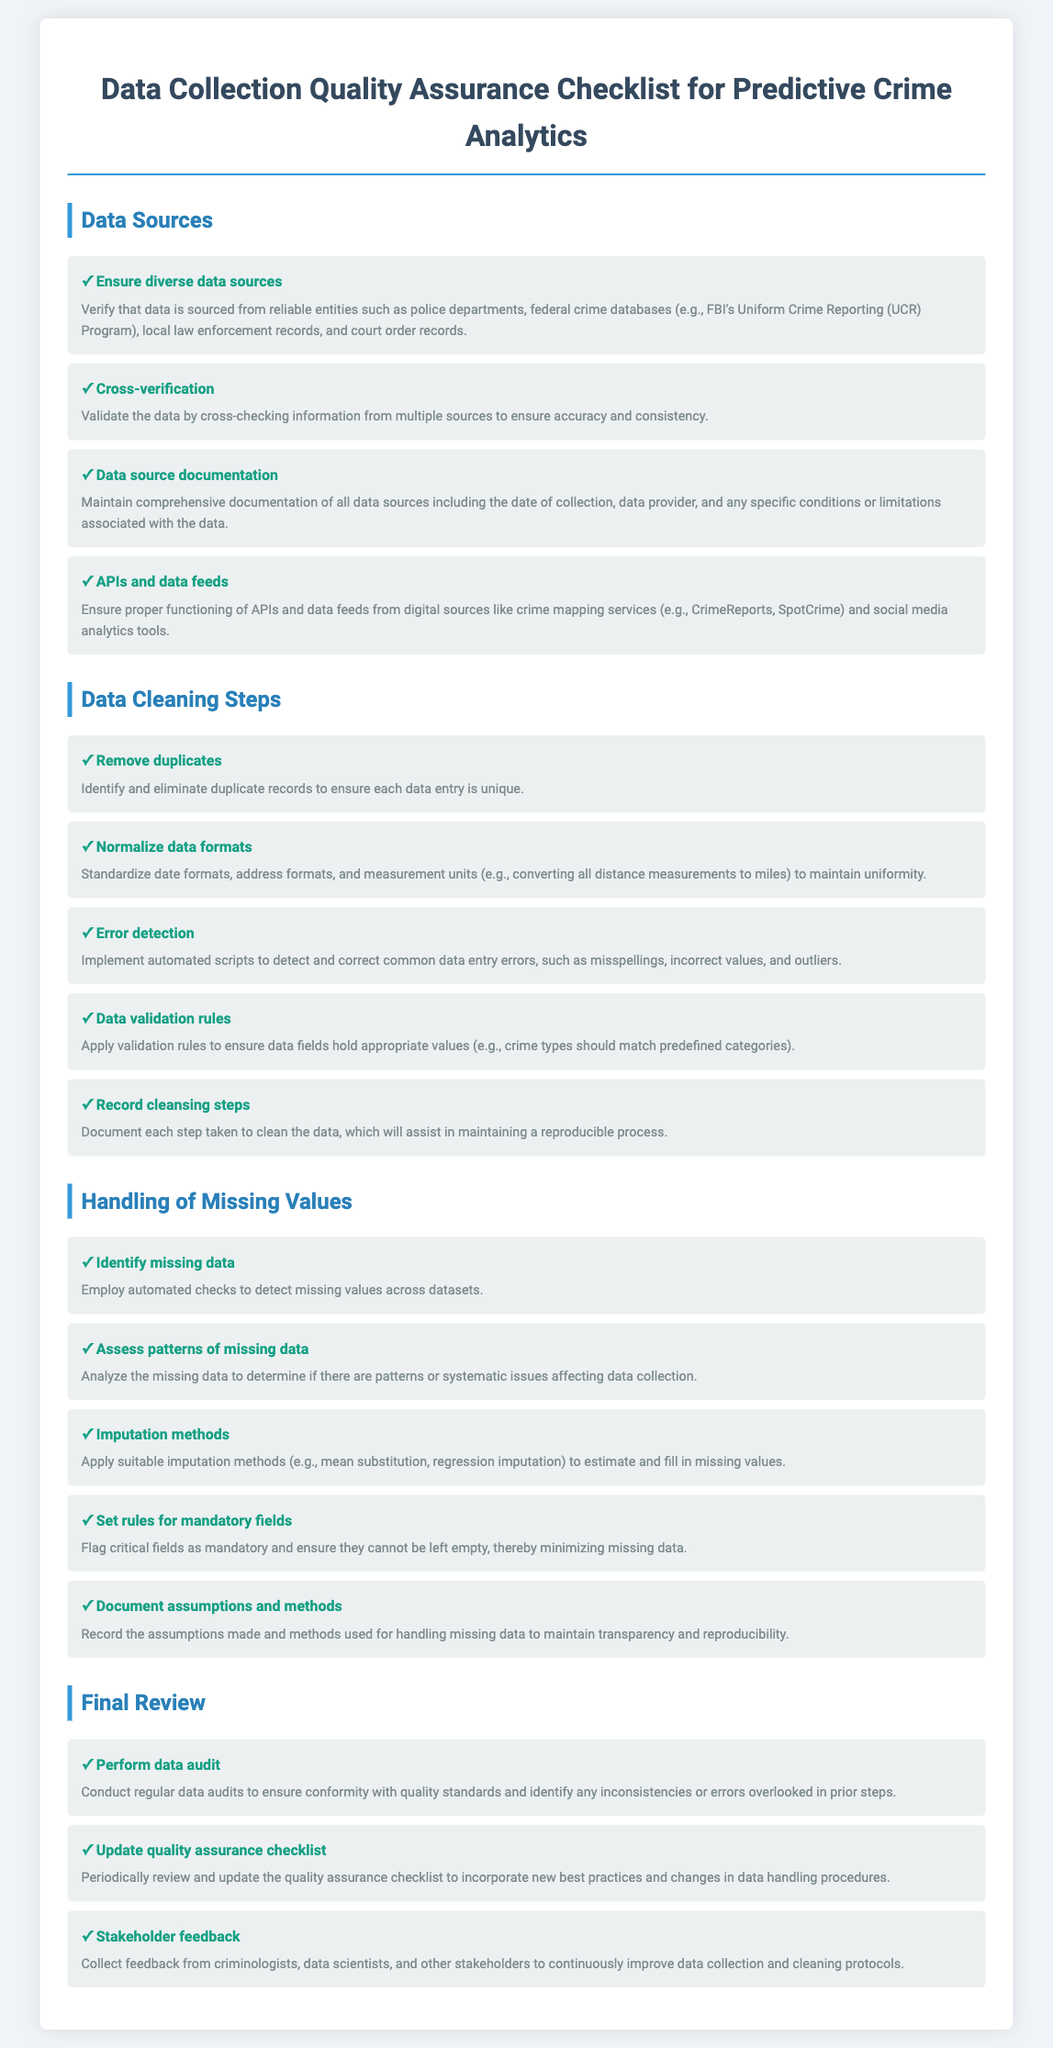what is the first item in the data sources section? The first item outlines the importance of sourcing data from diverse and reliable entities relevant to crime analytics.
Answer: Ensure diverse data sources how many items are listed under data cleaning steps? The document lists a total of five items in the data cleaning steps section.
Answer: 5 what should be flagged as mandatory in handling missing values? The document specifies that critical fields should be flagged to prevent them from being left empty.
Answer: Critical fields what is one method suggested for applying imputation? In the handling of missing values section, the document mentions mean substitution as a method for filling in missing values.
Answer: Mean substitution which section discusses the need for stakeholder feedback? The final review section includes a point about collecting feedback from relevant stakeholders to improve protocols.
Answer: Final Review how often should the quality assurance checklist be updated? The document recommends periodically reviewing and updating the quality assurance checklist.
Answer: Periodically what is one step mentioned for error detection in data cleaning? The document states that automated scripts can be used to detect and correct data entry errors.
Answer: Automated scripts what does the document recommend for data source documentation? It is suggested that there should be comprehensive documentation of all data sources, including relevant details.
Answer: Comprehensive documentation what is one benefit of cross-verification according to the document? Cross-verification helps to validate the data and ensure accuracy and consistency.
Answer: Accuracy and consistency 